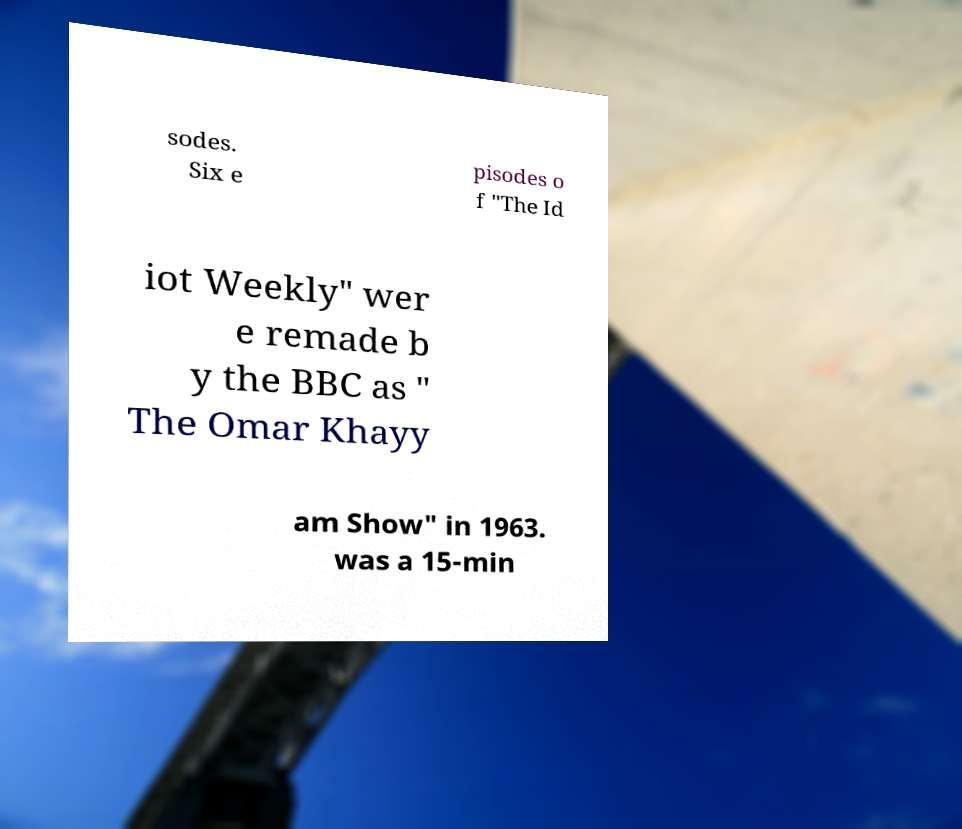Please read and relay the text visible in this image. What does it say? sodes. Six e pisodes o f "The Id iot Weekly" wer e remade b y the BBC as " The Omar Khayy am Show" in 1963. was a 15-min 